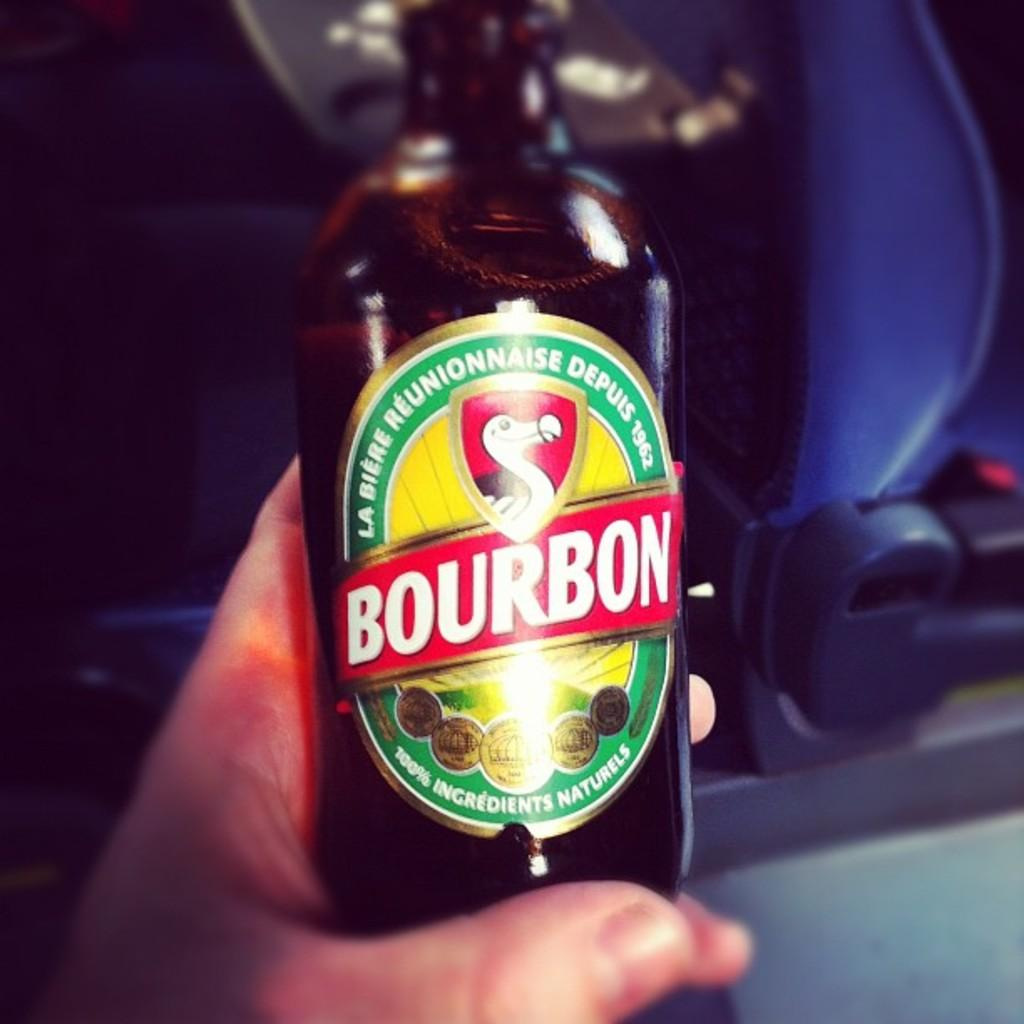<image>
Present a compact description of the photo's key features. A person holding a bottle of Bourbon 100% Ingredients Naturels. 